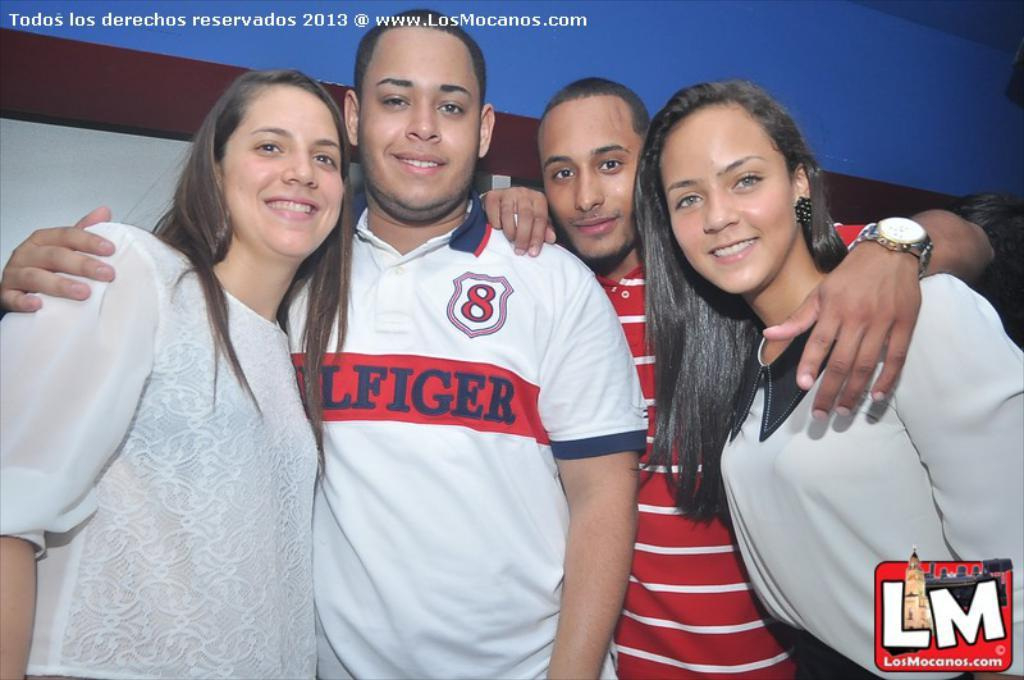How many people are present in the image? There are four people standing in the image. What are the people doing in the image? The people are posing for the picture. Can you describe any text visible in the image? Yes, there is text in the top left corner and the bottom right corner of the image. What type of berry is being used as a prop in the image? There is no berry present in the image. What grade is the person in the image receiving? There is no indication of a grade or any educational context in the image. 